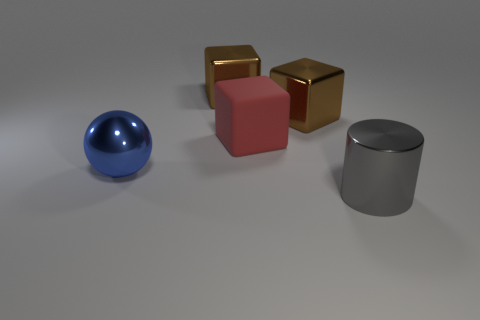What number of other large metal spheres have the same color as the metal ball?
Keep it short and to the point. 0. What size is the cylinder that is the same material as the ball?
Keep it short and to the point. Large. What is the shape of the big brown metal object on the left side of the rubber thing?
Keep it short and to the point. Cube. What number of large brown shiny blocks are behind the brown metallic block to the right of the brown block left of the red rubber object?
Keep it short and to the point. 1. Are there an equal number of big cylinders that are to the left of the large ball and large yellow rubber spheres?
Make the answer very short. Yes. How many cubes are either big blue metallic objects or big objects?
Offer a very short reply. 3. Does the big sphere have the same color as the shiny cylinder?
Make the answer very short. No. Are there an equal number of metal cylinders behind the big red cube and big shiny things in front of the cylinder?
Make the answer very short. Yes. What color is the large rubber cube?
Your response must be concise. Red. How many things are big metal objects that are behind the shiny sphere or gray metal cylinders?
Make the answer very short. 3. 